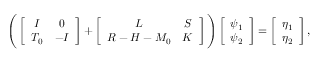<formula> <loc_0><loc_0><loc_500><loc_500>\begin{array} { r } { \left ( \left [ \begin{array} { c c } { I } & { 0 } \\ { T _ { 0 } } & { - I } \end{array} \right ] + \left [ \begin{array} { c c } { L } & { S } \\ { R - H - M _ { 0 } } & { K } \end{array} \right ] \right ) \left [ \begin{array} { c } { \psi _ { 1 } } \\ { \psi _ { 2 } } \end{array} \right ] = \left [ \begin{array} { c } { \eta _ { 1 } } \\ { \eta _ { 2 } } \end{array} \right ] , } \end{array}</formula> 